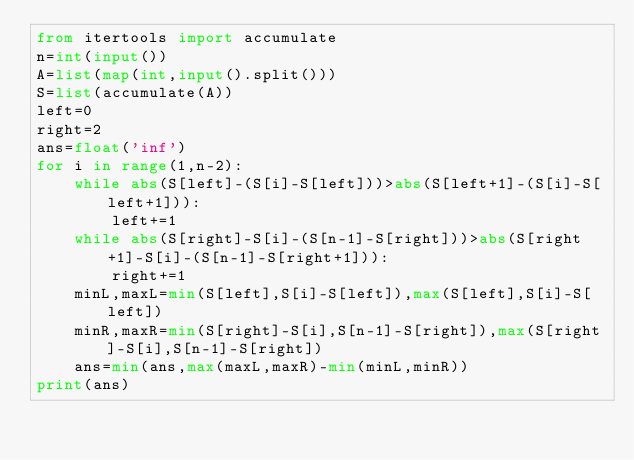<code> <loc_0><loc_0><loc_500><loc_500><_Python_>from itertools import accumulate
n=int(input())
A=list(map(int,input().split()))
S=list(accumulate(A))
left=0
right=2
ans=float('inf')
for i in range(1,n-2):
    while abs(S[left]-(S[i]-S[left]))>abs(S[left+1]-(S[i]-S[left+1])):
        left+=1
    while abs(S[right]-S[i]-(S[n-1]-S[right]))>abs(S[right+1]-S[i]-(S[n-1]-S[right+1])):
        right+=1
    minL,maxL=min(S[left],S[i]-S[left]),max(S[left],S[i]-S[left])
    minR,maxR=min(S[right]-S[i],S[n-1]-S[right]),max(S[right]-S[i],S[n-1]-S[right])
    ans=min(ans,max(maxL,maxR)-min(minL,minR))
print(ans)</code> 